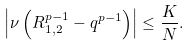Convert formula to latex. <formula><loc_0><loc_0><loc_500><loc_500>\left | \nu \left ( R _ { 1 , 2 } ^ { p - 1 } - q ^ { p - 1 } \right ) \right | \leq \frac { K } { N } .</formula> 